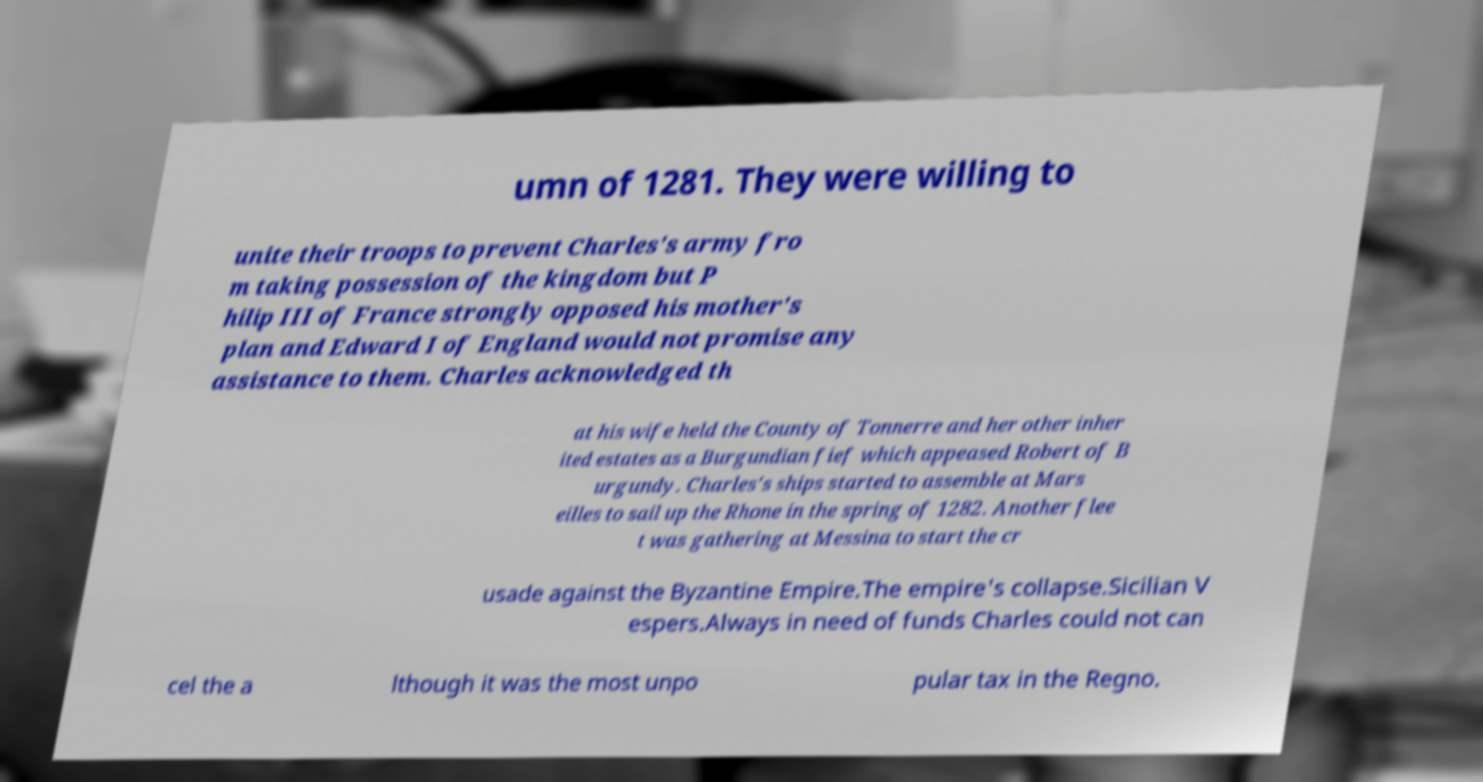Please read and relay the text visible in this image. What does it say? umn of 1281. They were willing to unite their troops to prevent Charles's army fro m taking possession of the kingdom but P hilip III of France strongly opposed his mother's plan and Edward I of England would not promise any assistance to them. Charles acknowledged th at his wife held the County of Tonnerre and her other inher ited estates as a Burgundian fief which appeased Robert of B urgundy. Charles's ships started to assemble at Mars eilles to sail up the Rhone in the spring of 1282. Another flee t was gathering at Messina to start the cr usade against the Byzantine Empire.The empire's collapse.Sicilian V espers.Always in need of funds Charles could not can cel the a lthough it was the most unpo pular tax in the Regno. 